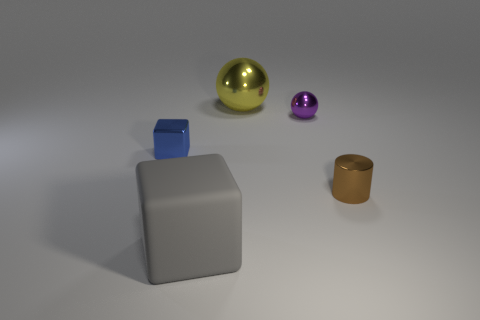Add 4 brown balls. How many objects exist? 9 Subtract all cylinders. How many objects are left? 4 Add 5 blue rubber things. How many blue rubber things exist? 5 Subtract 0 green cylinders. How many objects are left? 5 Subtract all large blue rubber cylinders. Subtract all shiny cubes. How many objects are left? 4 Add 4 rubber blocks. How many rubber blocks are left? 5 